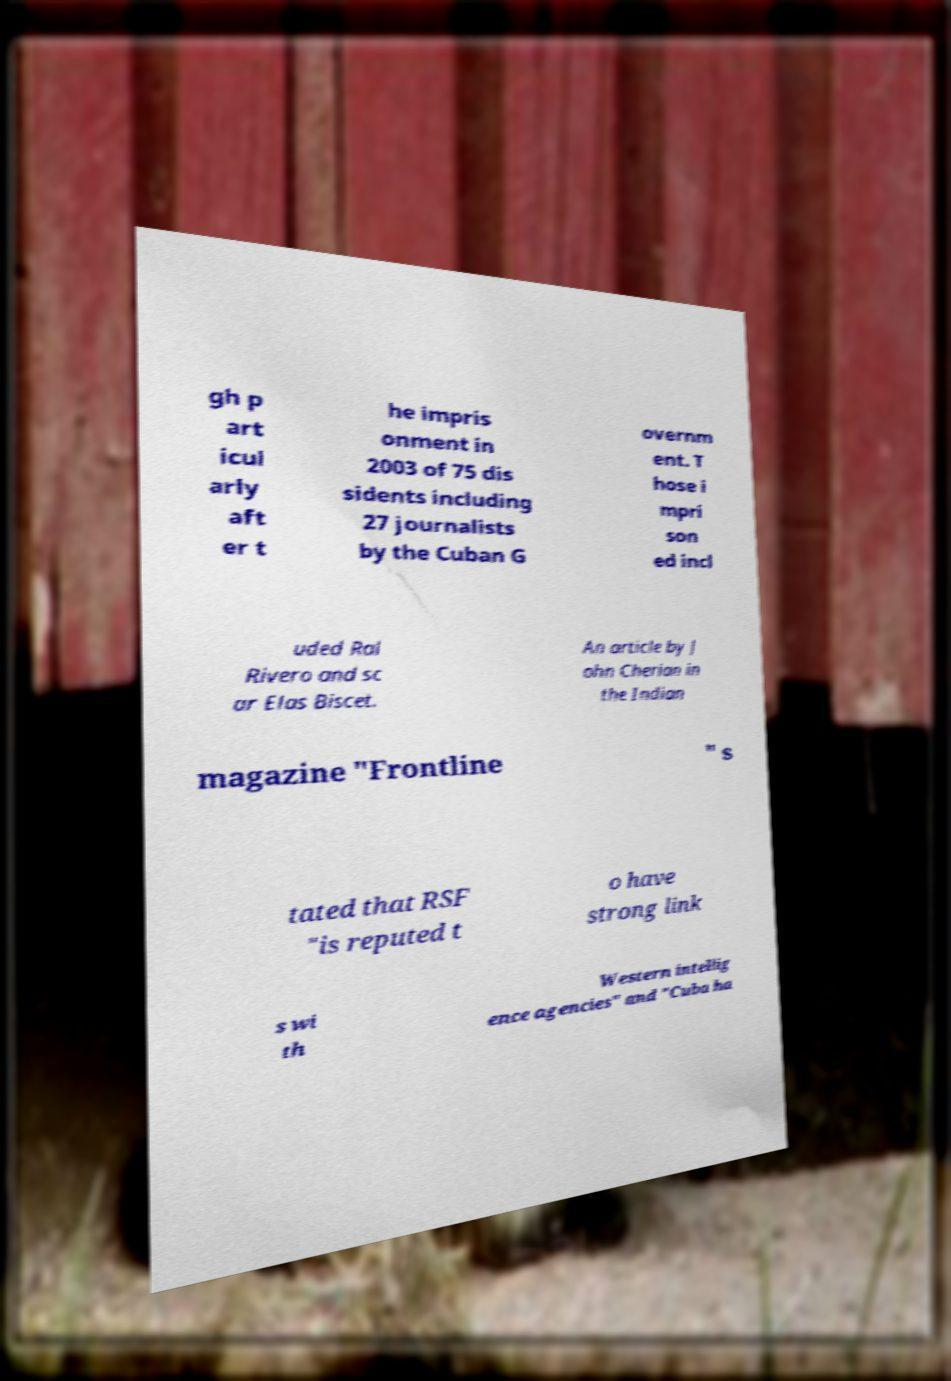What messages or text are displayed in this image? I need them in a readable, typed format. gh p art icul arly aft er t he impris onment in 2003 of 75 dis sidents including 27 journalists by the Cuban G overnm ent. T hose i mpri son ed incl uded Ral Rivero and sc ar Elas Biscet. An article by J ohn Cherian in the Indian magazine "Frontline " s tated that RSF "is reputed t o have strong link s wi th Western intellig ence agencies" and "Cuba ha 